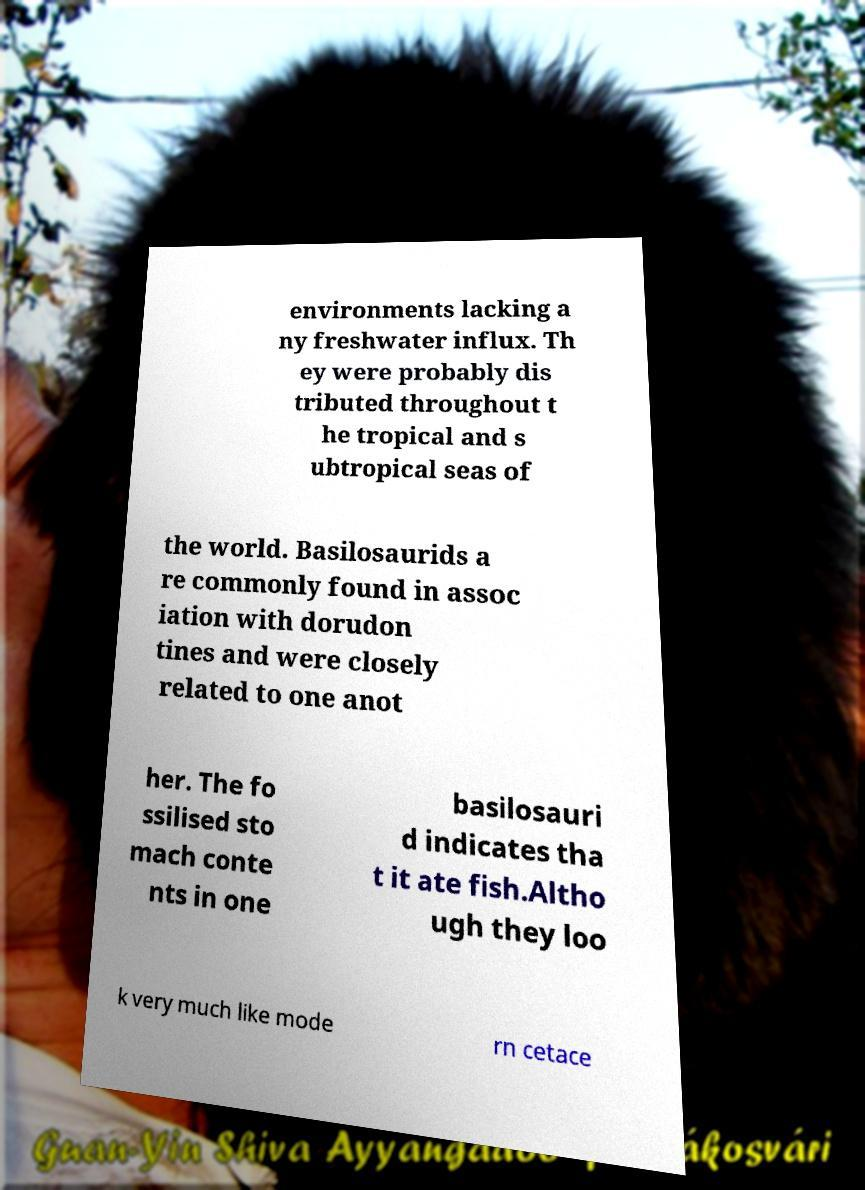Please identify and transcribe the text found in this image. environments lacking a ny freshwater influx. Th ey were probably dis tributed throughout t he tropical and s ubtropical seas of the world. Basilosaurids a re commonly found in assoc iation with dorudon tines and were closely related to one anot her. The fo ssilised sto mach conte nts in one basilosauri d indicates tha t it ate fish.Altho ugh they loo k very much like mode rn cetace 